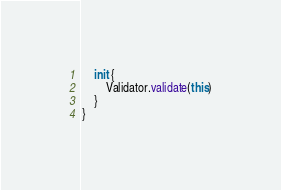<code> <loc_0><loc_0><loc_500><loc_500><_Kotlin_>    init {
        Validator.validate(this)
    }
}</code> 